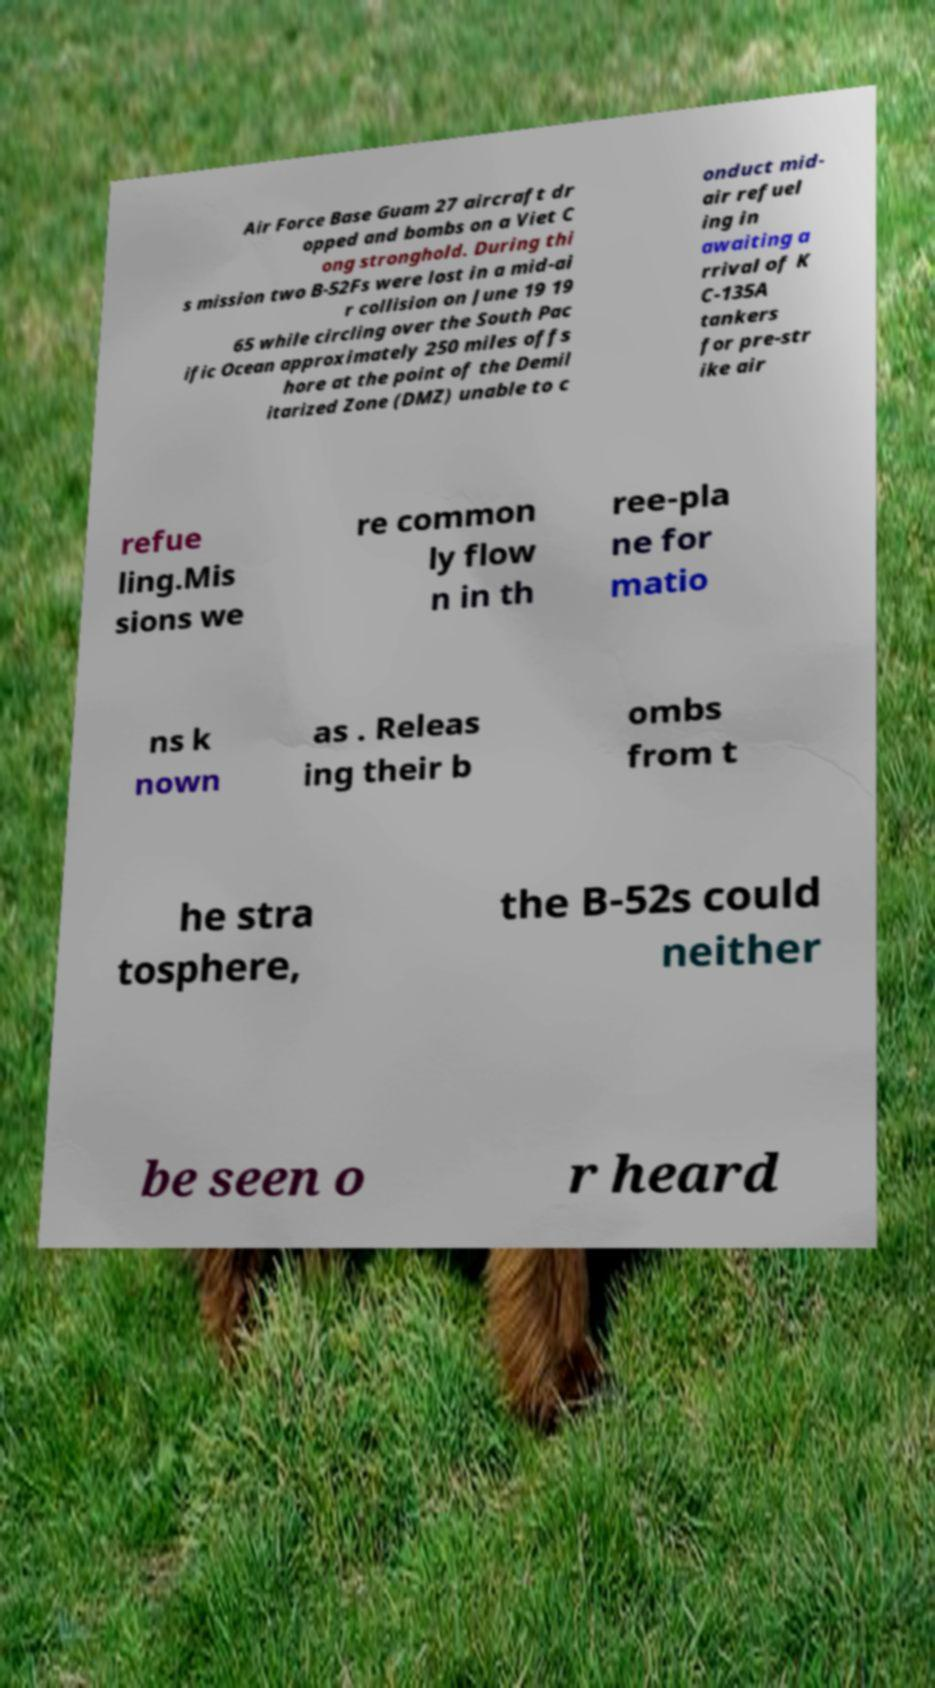There's text embedded in this image that I need extracted. Can you transcribe it verbatim? Air Force Base Guam 27 aircraft dr opped and bombs on a Viet C ong stronghold. During thi s mission two B-52Fs were lost in a mid-ai r collision on June 19 19 65 while circling over the South Pac ific Ocean approximately 250 miles offs hore at the point of the Demil itarized Zone (DMZ) unable to c onduct mid- air refuel ing in awaiting a rrival of K C-135A tankers for pre-str ike air refue ling.Mis sions we re common ly flow n in th ree-pla ne for matio ns k nown as . Releas ing their b ombs from t he stra tosphere, the B-52s could neither be seen o r heard 